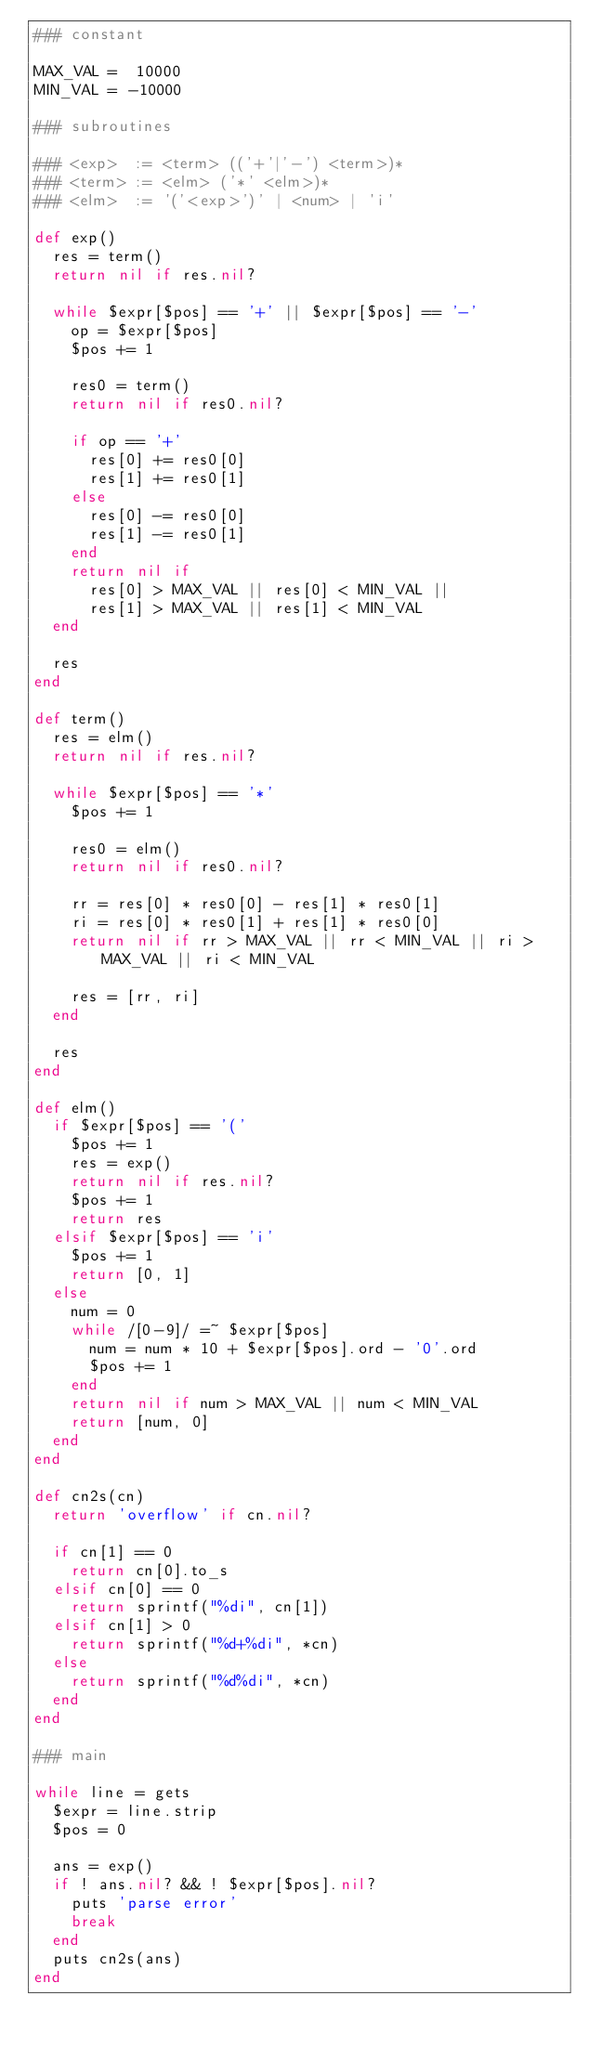Convert code to text. <code><loc_0><loc_0><loc_500><loc_500><_Ruby_>### constant

MAX_VAL =  10000
MIN_VAL = -10000

### subroutines

### <exp>  := <term> (('+'|'-') <term>)*
### <term> := <elm> ('*' <elm>)*
### <elm>  := '('<exp>')' | <num> | 'i'

def exp()
  res = term()
  return nil if res.nil?

  while $expr[$pos] == '+' || $expr[$pos] == '-'
    op = $expr[$pos]
    $pos += 1

    res0 = term()
    return nil if res0.nil?

    if op == '+'
      res[0] += res0[0]
      res[1] += res0[1]
    else
      res[0] -= res0[0]
      res[1] -= res0[1]
    end
    return nil if
      res[0] > MAX_VAL || res[0] < MIN_VAL ||
      res[1] > MAX_VAL || res[1] < MIN_VAL
  end

  res
end

def term()
  res = elm()
  return nil if res.nil?

  while $expr[$pos] == '*'
    $pos += 1

    res0 = elm()
    return nil if res0.nil?

    rr = res[0] * res0[0] - res[1] * res0[1]
    ri = res[0] * res0[1] + res[1] * res0[0]
    return nil if rr > MAX_VAL || rr < MIN_VAL || ri > MAX_VAL || ri < MIN_VAL

    res = [rr, ri]
  end

  res
end

def elm()
  if $expr[$pos] == '('
    $pos += 1
    res = exp()
    return nil if res.nil?
    $pos += 1
    return res
  elsif $expr[$pos] == 'i'
    $pos += 1
    return [0, 1]
  else
    num = 0
    while /[0-9]/ =~ $expr[$pos]
      num = num * 10 + $expr[$pos].ord - '0'.ord
      $pos += 1
    end
    return nil if num > MAX_VAL || num < MIN_VAL
    return [num, 0]
  end
end

def cn2s(cn)
  return 'overflow' if cn.nil?

  if cn[1] == 0
    return cn[0].to_s
  elsif cn[0] == 0
    return sprintf("%di", cn[1])
  elsif cn[1] > 0
    return sprintf("%d+%di", *cn)
  else
    return sprintf("%d%di", *cn)
  end
end

### main

while line = gets
  $expr = line.strip
  $pos = 0

  ans = exp()
  if ! ans.nil? && ! $expr[$pos].nil?
    puts 'parse error'
    break
  end
  puts cn2s(ans)
end</code> 